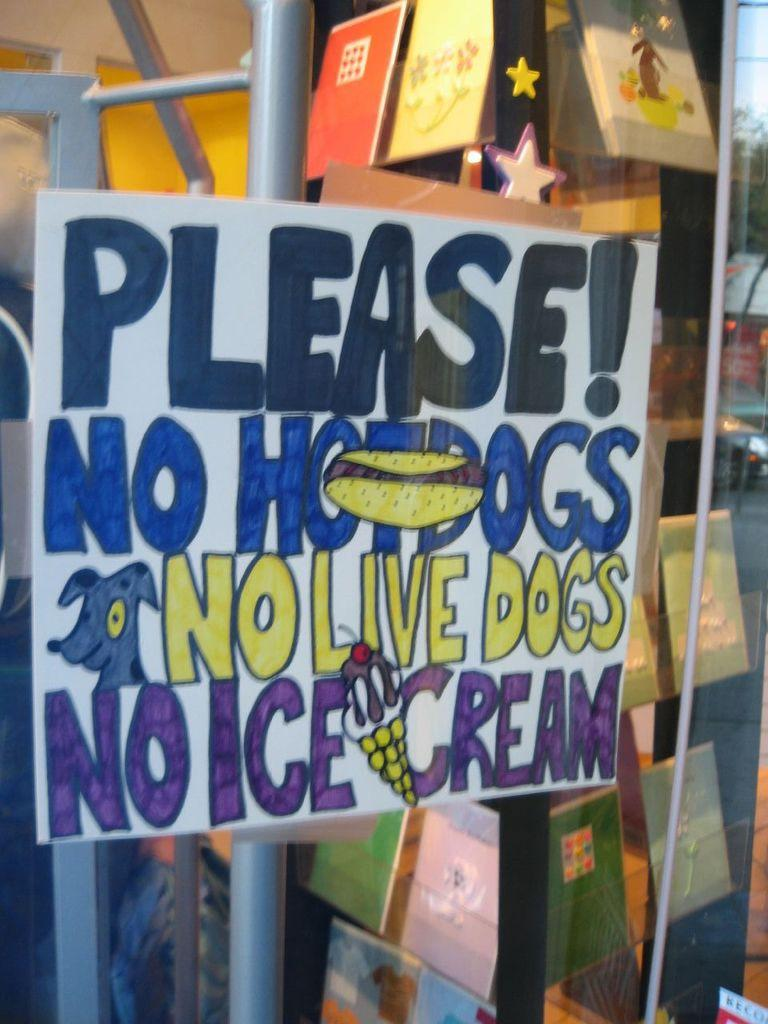<image>
Create a compact narrative representing the image presented. A handwritten sign on a store window asks no hotdogs or live dogs or ice cream come inside. 